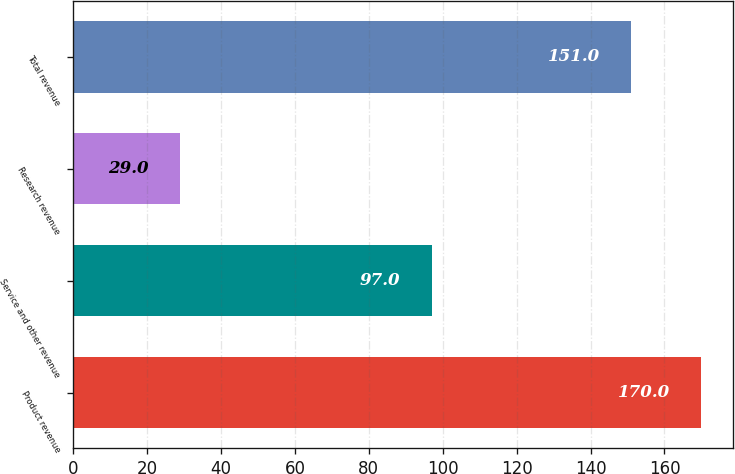Convert chart to OTSL. <chart><loc_0><loc_0><loc_500><loc_500><bar_chart><fcel>Product revenue<fcel>Service and other revenue<fcel>Research revenue<fcel>Total revenue<nl><fcel>170<fcel>97<fcel>29<fcel>151<nl></chart> 